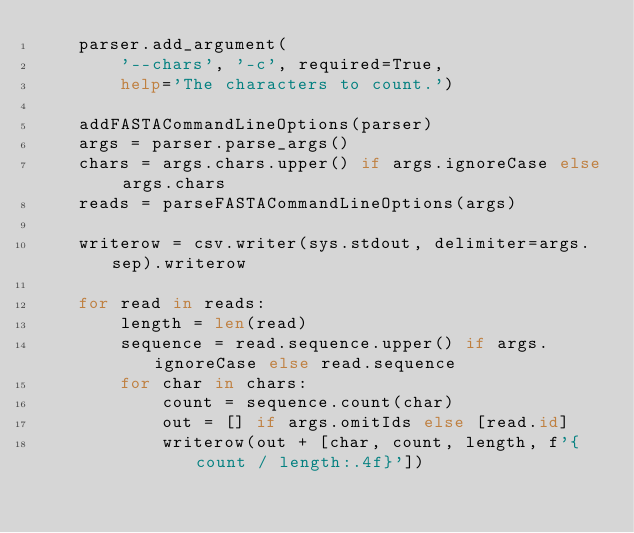Convert code to text. <code><loc_0><loc_0><loc_500><loc_500><_Python_>    parser.add_argument(
        '--chars', '-c', required=True,
        help='The characters to count.')

    addFASTACommandLineOptions(parser)
    args = parser.parse_args()
    chars = args.chars.upper() if args.ignoreCase else args.chars
    reads = parseFASTACommandLineOptions(args)

    writerow = csv.writer(sys.stdout, delimiter=args.sep).writerow

    for read in reads:
        length = len(read)
        sequence = read.sequence.upper() if args.ignoreCase else read.sequence
        for char in chars:
            count = sequence.count(char)
            out = [] if args.omitIds else [read.id]
            writerow(out + [char, count, length, f'{count / length:.4f}'])
</code> 